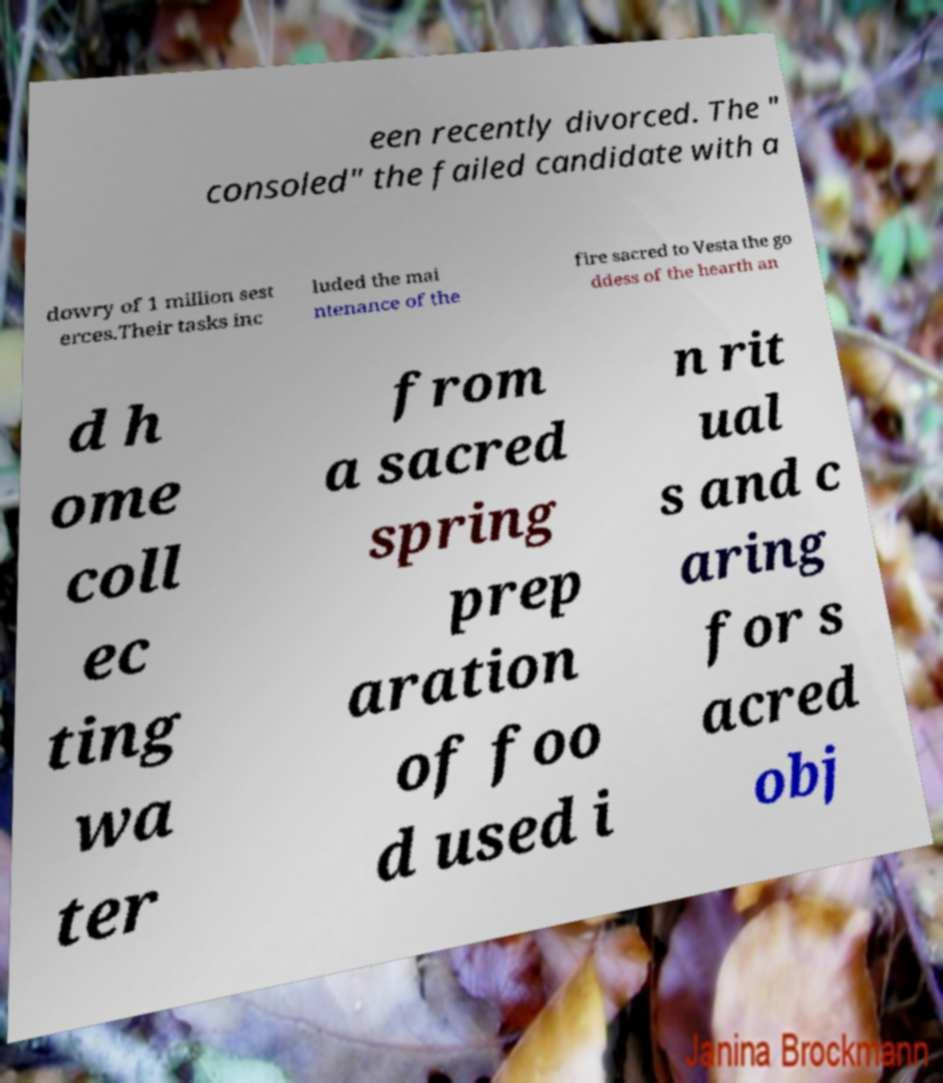Can you accurately transcribe the text from the provided image for me? een recently divorced. The " consoled" the failed candidate with a dowry of 1 million sest erces.Their tasks inc luded the mai ntenance of the fire sacred to Vesta the go ddess of the hearth an d h ome coll ec ting wa ter from a sacred spring prep aration of foo d used i n rit ual s and c aring for s acred obj 